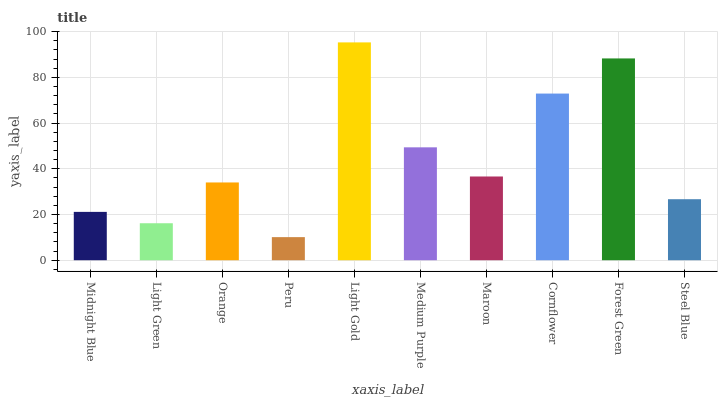Is Peru the minimum?
Answer yes or no. Yes. Is Light Gold the maximum?
Answer yes or no. Yes. Is Light Green the minimum?
Answer yes or no. No. Is Light Green the maximum?
Answer yes or no. No. Is Midnight Blue greater than Light Green?
Answer yes or no. Yes. Is Light Green less than Midnight Blue?
Answer yes or no. Yes. Is Light Green greater than Midnight Blue?
Answer yes or no. No. Is Midnight Blue less than Light Green?
Answer yes or no. No. Is Maroon the high median?
Answer yes or no. Yes. Is Orange the low median?
Answer yes or no. Yes. Is Light Green the high median?
Answer yes or no. No. Is Cornflower the low median?
Answer yes or no. No. 